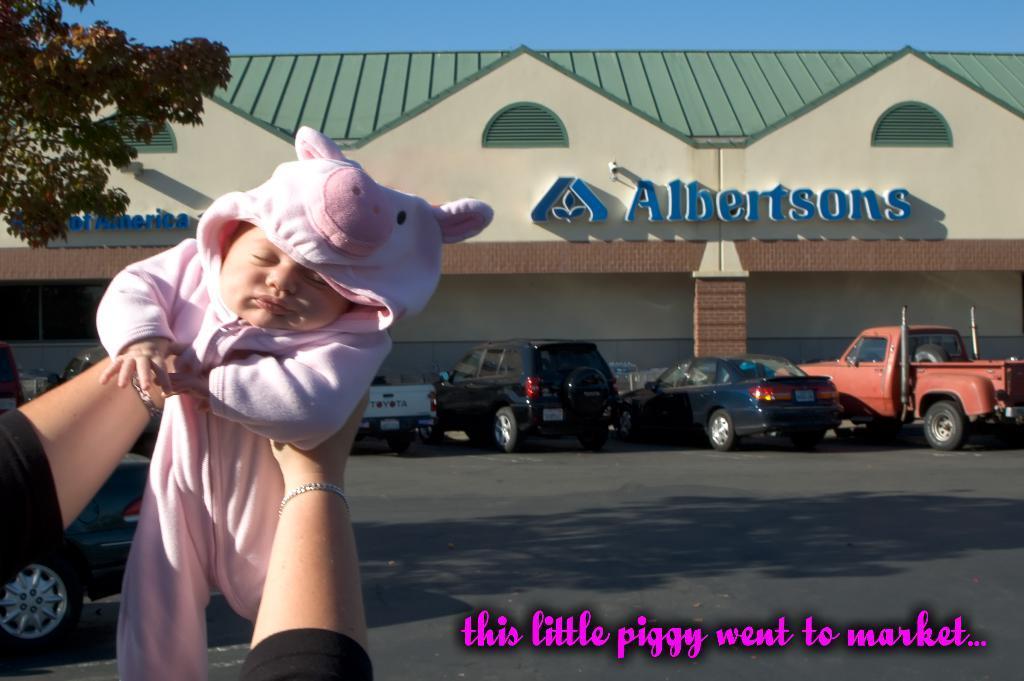In one or two sentences, can you explain what this image depicts? This picture is clicked on the road. There are cars parked on the road. Behind the cars there is a house. There is text on the walls of the house. At the top there is the sky. In the top left there are leaves of a tree. In the bottom left there are hands of a person holding an infant. At the bottom there is text on the image. 